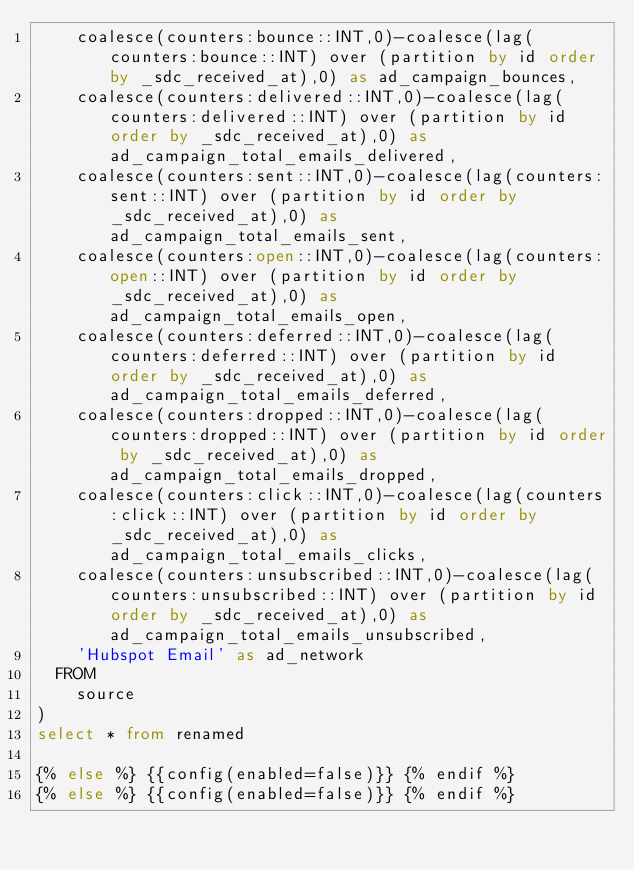Convert code to text. <code><loc_0><loc_0><loc_500><loc_500><_SQL_>    coalesce(counters:bounce::INT,0)-coalesce(lag(counters:bounce::INT) over (partition by id order by _sdc_received_at),0) as ad_campaign_bounces,
    coalesce(counters:delivered::INT,0)-coalesce(lag(counters:delivered::INT) over (partition by id order by _sdc_received_at),0) as ad_campaign_total_emails_delivered,
    coalesce(counters:sent::INT,0)-coalesce(lag(counters:sent::INT) over (partition by id order by _sdc_received_at),0) as ad_campaign_total_emails_sent,
    coalesce(counters:open::INT,0)-coalesce(lag(counters:open::INT) over (partition by id order by _sdc_received_at),0) as ad_campaign_total_emails_open,
    coalesce(counters:deferred::INT,0)-coalesce(lag(counters:deferred::INT) over (partition by id order by _sdc_received_at),0) as ad_campaign_total_emails_deferred,
    coalesce(counters:dropped::INT,0)-coalesce(lag(counters:dropped::INT) over (partition by id order by _sdc_received_at),0) as ad_campaign_total_emails_dropped,
    coalesce(counters:click::INT,0)-coalesce(lag(counters:click::INT) over (partition by id order by _sdc_received_at),0) as ad_campaign_total_emails_clicks,
    coalesce(counters:unsubscribed::INT,0)-coalesce(lag(counters:unsubscribed::INT) over (partition by id order by _sdc_received_at),0) as ad_campaign_total_emails_unsubscribed,
    'Hubspot Email' as ad_network
  FROM
    source
)
select * from renamed

{% else %} {{config(enabled=false)}} {% endif %}
{% else %} {{config(enabled=false)}} {% endif %}
</code> 